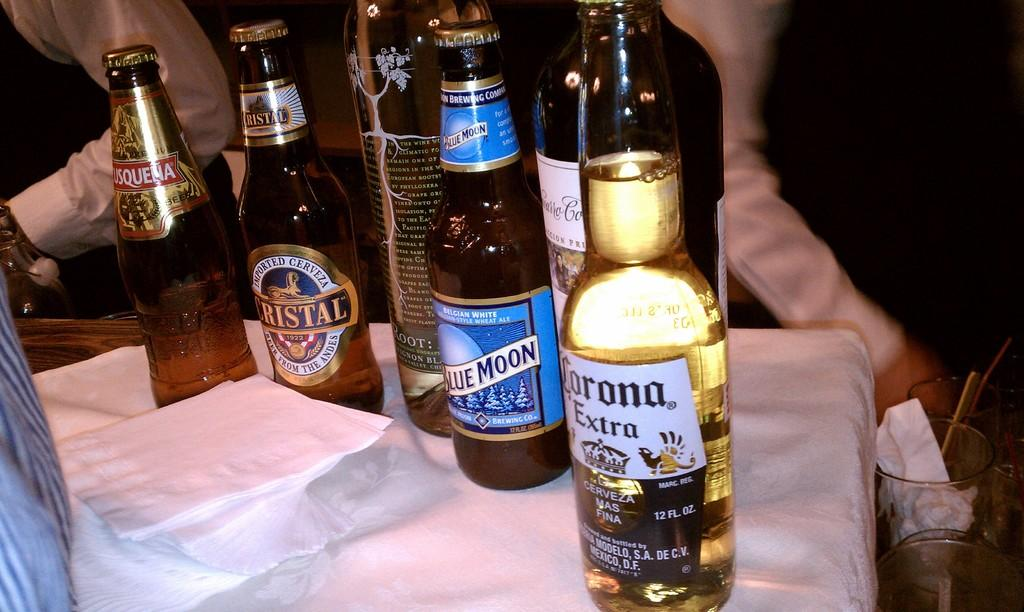<image>
Provide a brief description of the given image. Bottle of Corona Extra next to a bottle of Blue Moon. 